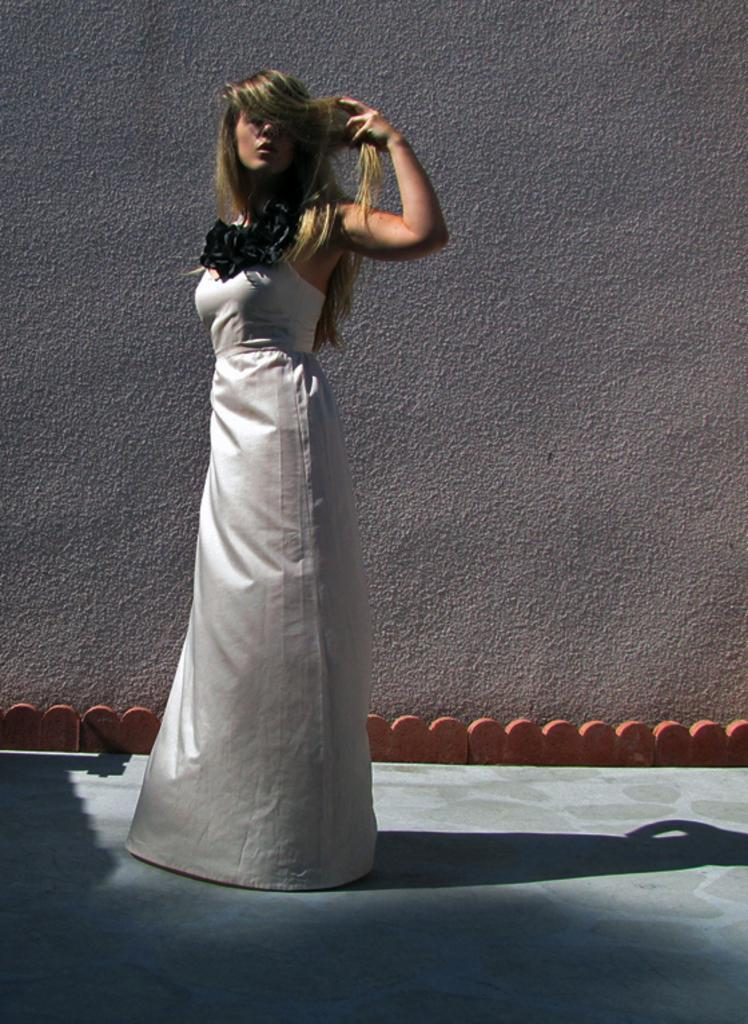What is the main subject of the image? There is a woman standing in the image. What can be observed about the woman's shadow in the image? The woman's shadow is visible at the bottom of the image. What is visible in the background of the image? There is a wall in the background of the image. Can you see any cobwebs on the wall in the image? There is no mention of cobwebs in the provided facts, so we cannot determine if any are present in the image. 